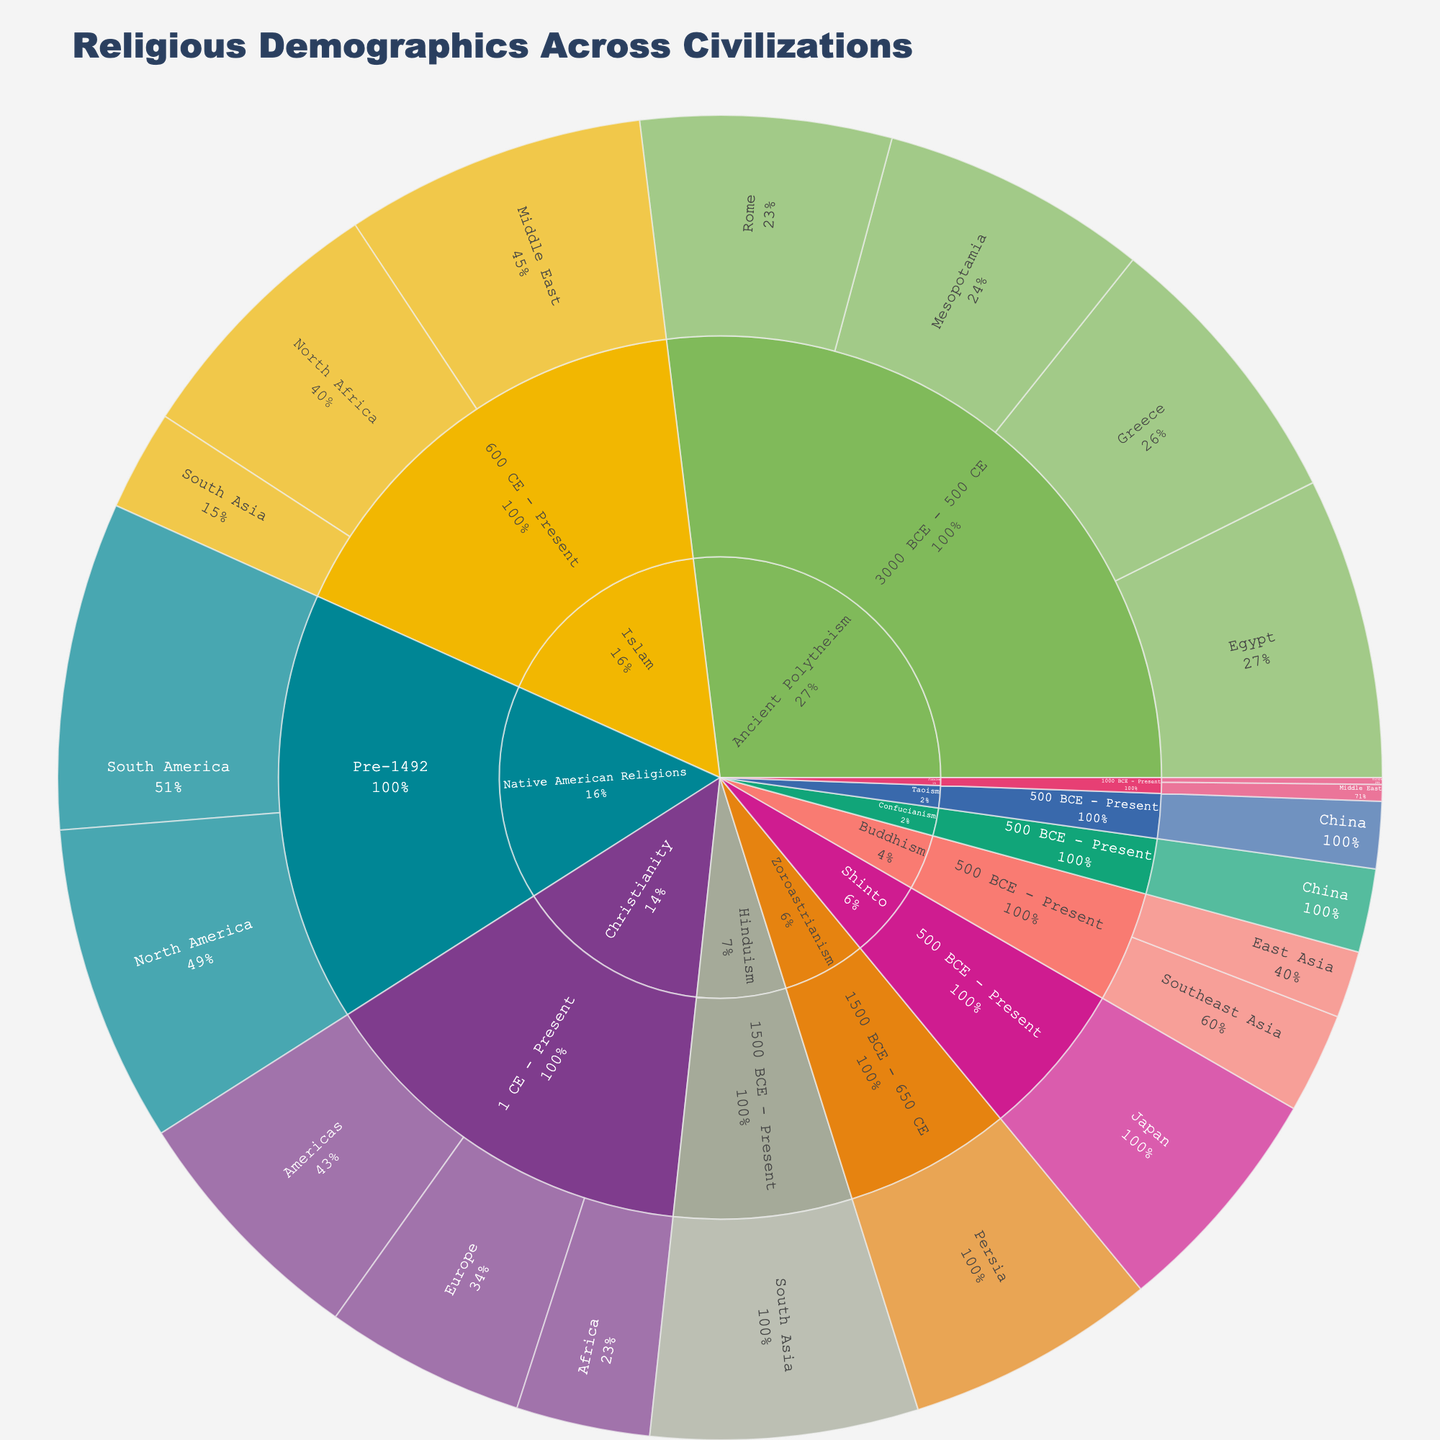What is the title of the figure? The title of the figure is displayed prominently at the top, typically in larger and bold font to make it easily recognizable. By looking at the title, you can understand the overall topic or subject of the visualization.
Answer: Religious Demographics Across Civilizations Which religion has the highest percentage in the Americas region from 1 CE to Present? To find the answer, first, locate the Christianity section, then navigate to the period 1 CE - Present. Within this period, identify the regions and their respective percentages.
Answer: Christianity What percentage of Ancient Polytheism was practiced in Mesopotamia? Find the Ancient Polytheism section in the sunburst plot, identify the different periods, and locate Mesopotamia to see its percentage in the Ancient Polytheism category.
Answer: 80% How many distinct periods are covered in the figure? Observe the hierarchical breakdown within the sunburst plot. By counting the distinct period labels shown, you can determine the number of different periods represented.
Answer: 5 Compare the representation of Buddhism between East Asia and Southeast Asia. Which region has a higher percentage? Trace the Buddhism section of the sunburst plot and identify the regions East Asia and Southeast Asia. Compare the percentages listed for each of these regions to determine which one is higher.
Answer: Southeast Asia What is the total percentage for Islam across all its regions combined? Identify all regions where Islam is represented and sum their percentages. In this plot, the relevant regions are Middle East, North Africa, and South Asia with percentages 90, 80, and 30 respectively. Calculation: 90 + 80 + 30 = 200
Answer: 200% Which region had the highest percentage of Native American Religions pre-1492? Within the Native American Religions section, find the period labeled Pre-1492 and identify the regions. Compare the percentages for North America and South America.
Answer: South America What is the combined percentage of Christianity in Europe and the Americas? Locate Christianity, then find the percentages for Europe and the Americas. Sum these percentages (60 + 75) to get the combined percentage.
Answer: 135% Identify the civilization with the least representation of Judaism. Locate the Judaism section within the timeline, then compare the percentages associated with each region (Europe and Middle East). Identify the region with the smallest percentage.
Answer: Europe Compare the influence of Ancient Polytheism in Egypt and Rome. Which civilization had a greater percentage? Explore the Ancient Polytheism section and find Egypt and Rome. Compare the percentages that are available for these regions to understand which had a larger representation.
Answer: Egypt 